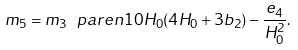<formula> <loc_0><loc_0><loc_500><loc_500>m _ { 5 } = m _ { 3 } \ p a r e n { 1 0 H _ { 0 } ( 4 H _ { 0 } + 3 b _ { 2 } ) - \frac { e _ { 4 } } { H _ { 0 } ^ { 2 } } } .</formula> 